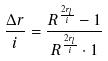Convert formula to latex. <formula><loc_0><loc_0><loc_500><loc_500>\frac { \Delta r } { i } = \frac { R ^ { \frac { 2 r _ { l } } { i } } - 1 } { R ^ { \frac { 2 r _ { l } } { i } } \cdot 1 }</formula> 